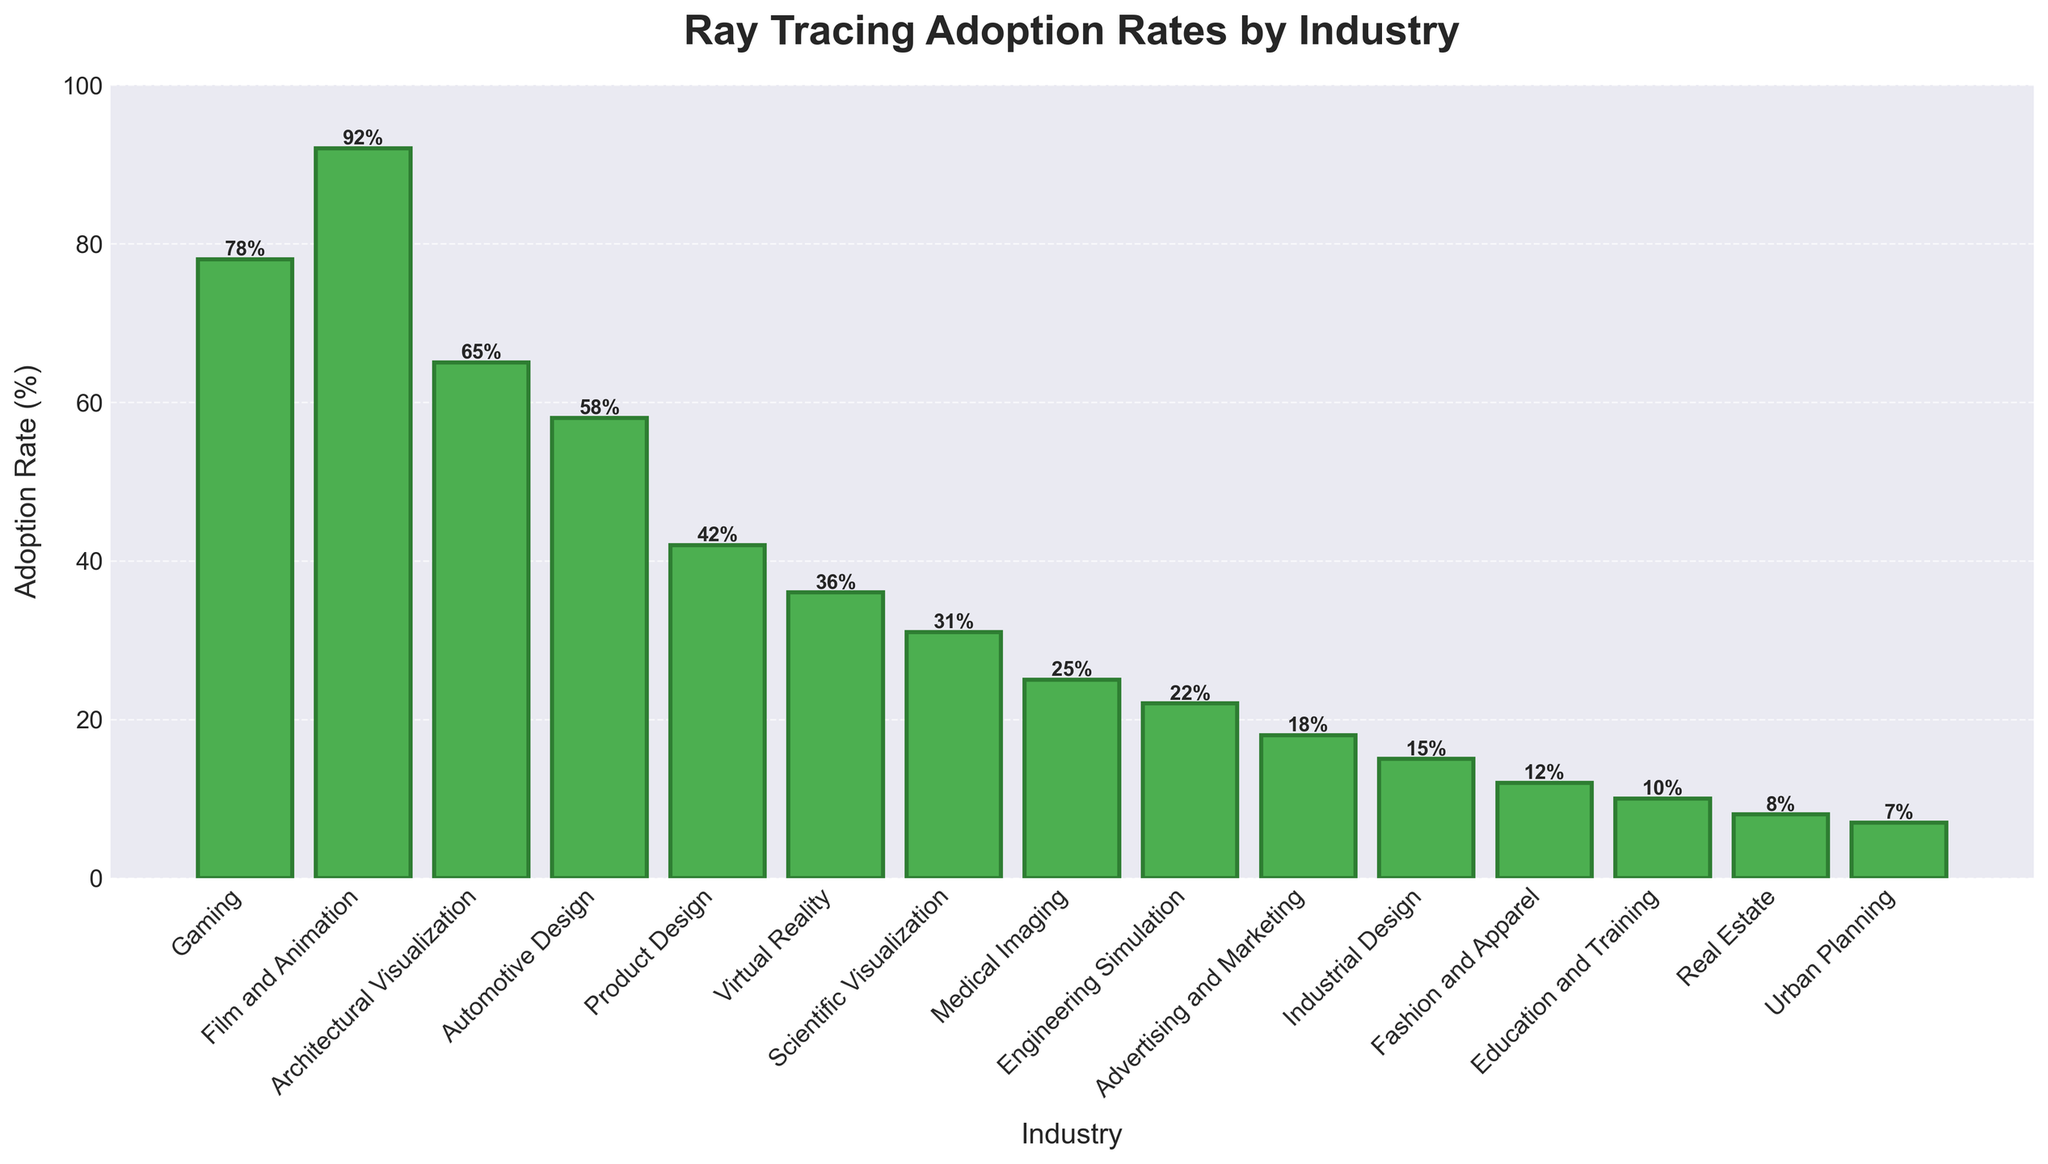What's the adoption rate of ray tracing technology in the Real Estate industry? The height of the bar for the Real Estate industry represents the adoption rate. Looking at it, we see that the bar is labeled with "8%".
Answer: 8% Which industry has the highest adoption rate of ray tracing technology? Observing the bars, the Film and Animation industry has the tallest bar, representing the highest adoption rate of "92%".
Answer: Film and Animation How much higher is the adoption rate in Gaming compared to Virtual Reality? The adoption rate in Gaming is 78%, whereas in Virtual Reality it is 36%. The difference is 78% - 36% = 42%.
Answer: 42% What is the total adoption rate percentage for the top three industries? The top three industries by adoption rate are Film and Animation (92%), Gaming (78%), and Architectural Visualization (65%). Summing these rates gives 92% + 78% + 65% = 235%.
Answer: 235% What is the average adoption rate for the Scientific Visualization, Medical Imaging, and Engineering Simulation industries? The adoption rates are 31%, 25%, and 22%, respectively. Adding these together gives 31% + 25% + 22% = 78%. Dividing by the number of industries (3) gives an average of 78% / 3 = 26%.
Answer: 26% Which industries have a lower adoption rate than Education and Training? Education and Training has an adoption rate of 10%. The industries with lower adoption rates are Real Estate (8%) and Urban Planning (7%).
Answer: Real Estate, Urban Planning Is the combined adoption rate for Advertising and Marketing, Industrial Design, and Fashion and Apparel less than the adoption rate for Gaming? The adoption rates are 18%, 15%, and 12% respectively, with a combined rate of 18% + 15% + 12% = 45%. Comparing this to Gaming's rate of 78%, we see 45% < 78%.
Answer: Yes What visual attribute indicates the adoption rate percentage in the figure? The height of the bars visually represents the adoption rate percentage, with numerical labels at the top of each bar confirming the exact rates.
Answer: Bar height Which industry shows a ray tracing adoption rate exactly in the middle between Architectural Visualization and Product Design? Architectural Visualization has an adoption rate of 65%, and Product Design has 42%. The middle value (average) between these is (65% + 42%) / 2 = 53.5%. The closest industry to this adoption rate is Automotive Design with 58%.
Answer: Automotive Design 